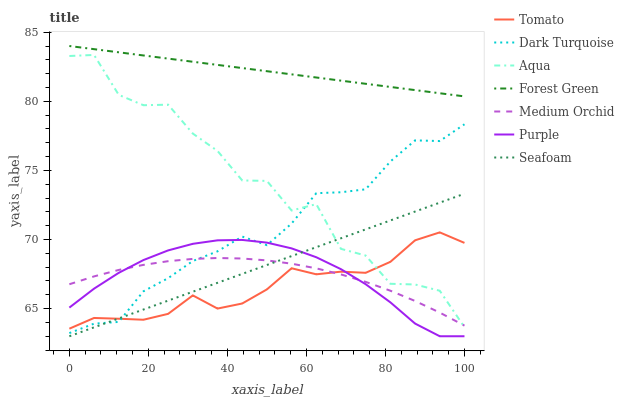Does Tomato have the minimum area under the curve?
Answer yes or no. Yes. Does Forest Green have the maximum area under the curve?
Answer yes or no. Yes. Does Purple have the minimum area under the curve?
Answer yes or no. No. Does Purple have the maximum area under the curve?
Answer yes or no. No. Is Forest Green the smoothest?
Answer yes or no. Yes. Is Aqua the roughest?
Answer yes or no. Yes. Is Purple the smoothest?
Answer yes or no. No. Is Purple the roughest?
Answer yes or no. No. Does Purple have the lowest value?
Answer yes or no. Yes. Does Dark Turquoise have the lowest value?
Answer yes or no. No. Does Forest Green have the highest value?
Answer yes or no. Yes. Does Purple have the highest value?
Answer yes or no. No. Is Purple less than Forest Green?
Answer yes or no. Yes. Is Forest Green greater than Tomato?
Answer yes or no. Yes. Does Seafoam intersect Tomato?
Answer yes or no. Yes. Is Seafoam less than Tomato?
Answer yes or no. No. Is Seafoam greater than Tomato?
Answer yes or no. No. Does Purple intersect Forest Green?
Answer yes or no. No. 